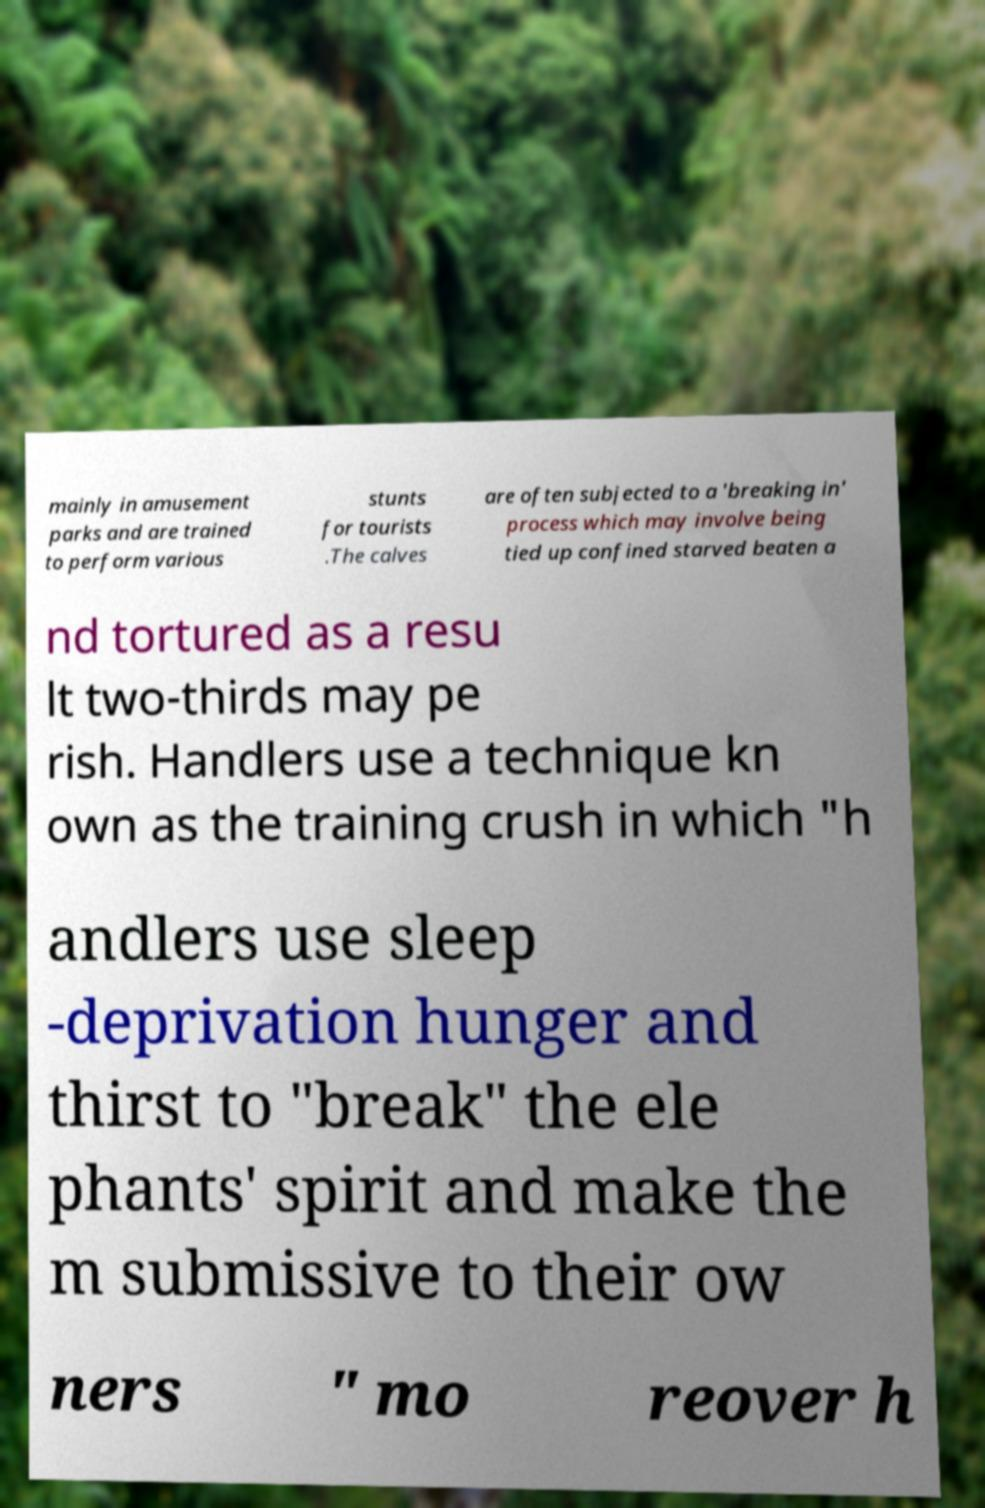Could you extract and type out the text from this image? mainly in amusement parks and are trained to perform various stunts for tourists .The calves are often subjected to a 'breaking in' process which may involve being tied up confined starved beaten a nd tortured as a resu lt two-thirds may pe rish. Handlers use a technique kn own as the training crush in which "h andlers use sleep -deprivation hunger and thirst to "break" the ele phants' spirit and make the m submissive to their ow ners " mo reover h 